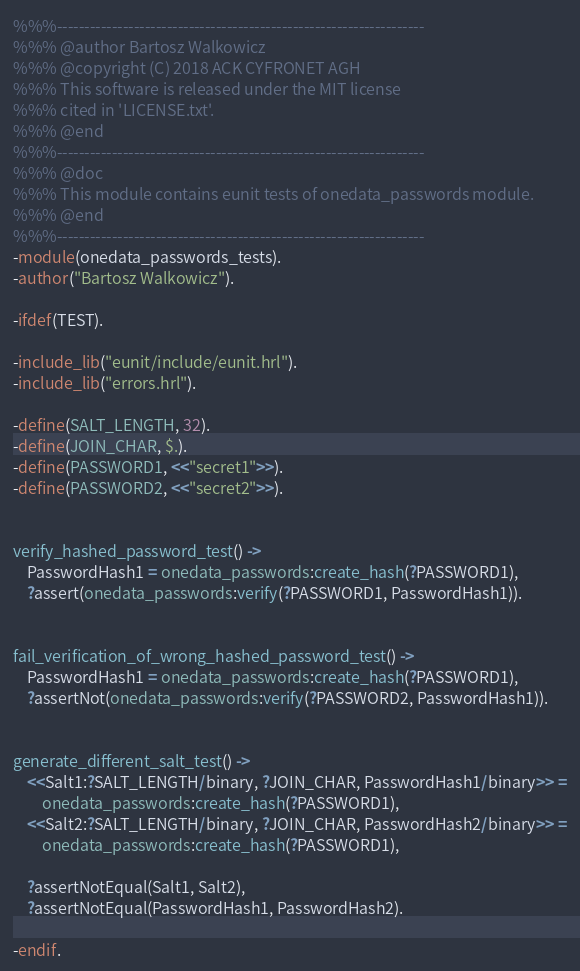Convert code to text. <code><loc_0><loc_0><loc_500><loc_500><_Erlang_>%%%-------------------------------------------------------------------
%%% @author Bartosz Walkowicz
%%% @copyright (C) 2018 ACK CYFRONET AGH
%%% This software is released under the MIT license
%%% cited in 'LICENSE.txt'.
%%% @end
%%%-------------------------------------------------------------------
%%% @doc
%%% This module contains eunit tests of onedata_passwords module.
%%% @end
%%%-------------------------------------------------------------------
-module(onedata_passwords_tests).
-author("Bartosz Walkowicz").

-ifdef(TEST).

-include_lib("eunit/include/eunit.hrl").
-include_lib("errors.hrl").

-define(SALT_LENGTH, 32).
-define(JOIN_CHAR, $.).
-define(PASSWORD1, <<"secret1">>).
-define(PASSWORD2, <<"secret2">>).


verify_hashed_password_test() ->
    PasswordHash1 = onedata_passwords:create_hash(?PASSWORD1),
    ?assert(onedata_passwords:verify(?PASSWORD1, PasswordHash1)).


fail_verification_of_wrong_hashed_password_test() ->
    PasswordHash1 = onedata_passwords:create_hash(?PASSWORD1),
    ?assertNot(onedata_passwords:verify(?PASSWORD2, PasswordHash1)).


generate_different_salt_test() ->
    <<Salt1:?SALT_LENGTH/binary, ?JOIN_CHAR, PasswordHash1/binary>> =
        onedata_passwords:create_hash(?PASSWORD1),
    <<Salt2:?SALT_LENGTH/binary, ?JOIN_CHAR, PasswordHash2/binary>> =
        onedata_passwords:create_hash(?PASSWORD1),

    ?assertNotEqual(Salt1, Salt2),
    ?assertNotEqual(PasswordHash1, PasswordHash2).

-endif.
</code> 